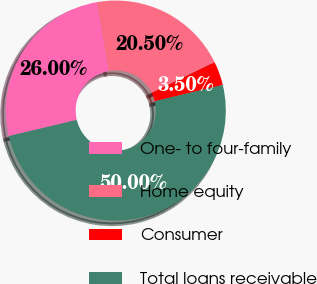Convert chart to OTSL. <chart><loc_0><loc_0><loc_500><loc_500><pie_chart><fcel>One- to four-family<fcel>Home equity<fcel>Consumer<fcel>Total loans receivable<nl><fcel>26.0%<fcel>20.5%<fcel>3.5%<fcel>50.0%<nl></chart> 